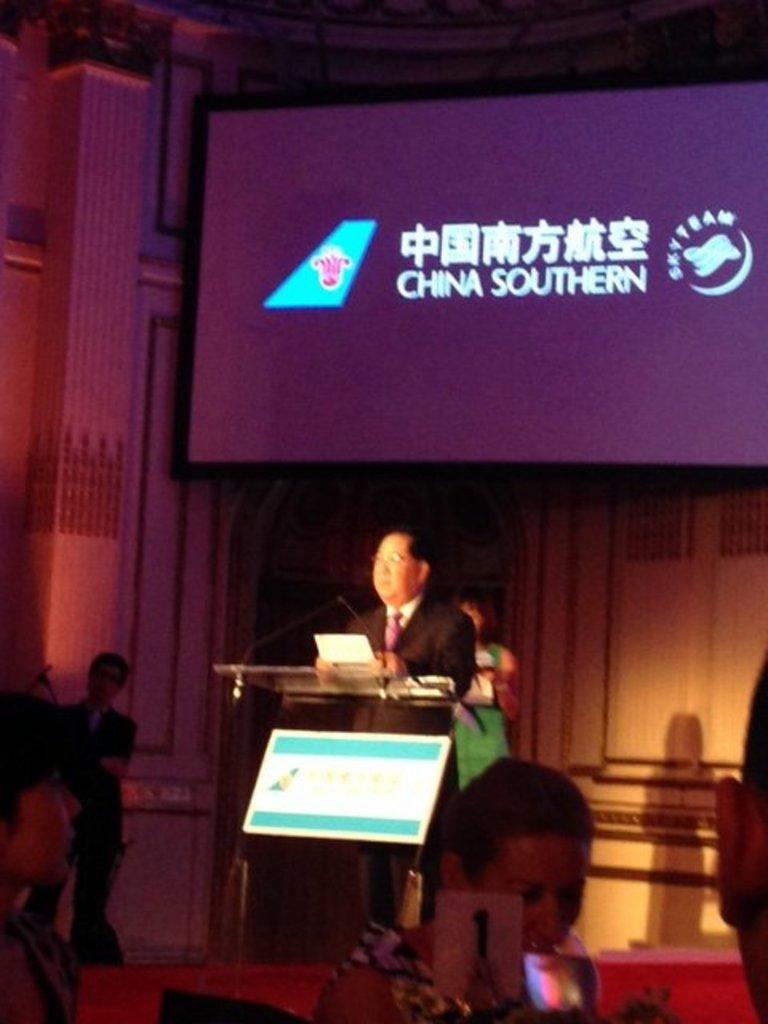Who or what can be seen in the image? There are people in the image. What is in the glass that is visible in the image? There is a glass with a drink in it. What object is present for speaking purposes in the image? There are microphones (mics) in the image. What is the purpose of the podium in the image? The podium is likely used for presentations or speeches. What is the paper used for in the image? The paper might be used for notes or a speech. What type of display devices are present in the image? There are screens in the image. What is the background of the image? There is a wall in the background of the image. What type of battle is taking place in the image? There is no battle present in the image; it features people, a glass with a drink, a podium, a paper, microphones, screens, and a wall in the background. What color is the stocking on the person in the image? There is no stocking visible on any person in the image. 